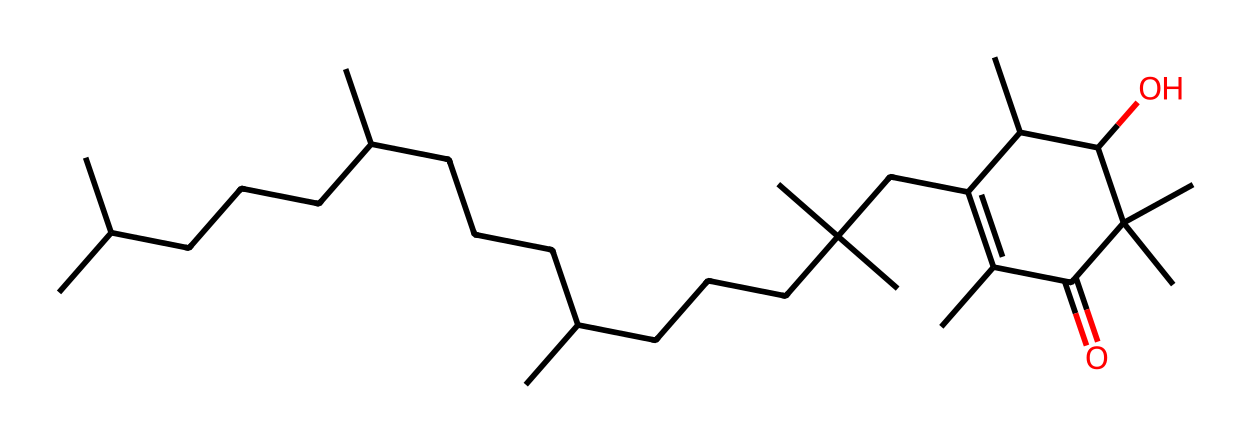What is the molecular formula of vitamin E? To determine the molecular formula from the provided SMILES, we need to count the number of each type of atom present in the chemical structure. Analyzing the SMILES reveals the presence of multiple carbon (C), hydrogen (H), and oxygen (O) atoms. The final count gives the formula: C29H50O2.
Answer: C29H50O2 How many oxygen atoms are present in vitamin E? By examining the SMILES representation, we can identify the number of oxygen atoms indicated by the 'O's present in the structure. Looking closely, there are exactly 2 oxygen atoms in vitamin E.
Answer: 2 What type of chemical bond predominates in vitamin E? The majority of connections made between carbon and hydrogen atoms in vitamin E are single bonds, which can be inferred from the structure's overall connectivity. This indicates that the predominant type of bond in vitamin E is the single bond.
Answer: single bond Does vitamin E have any double bonds in its structure? By inspecting the structure for any double bond indications (e.g., '=' in the SMILES), we find that there are indeed double bonds present, specifically between certain carbon atoms. This suggests that vitamin E contains double bonds in its structure.
Answer: yes What functional group is associated with the antioxidant properties of vitamin E? The antioxidant properties of vitamin E are largely attributed to the presence of the hydroxyl (-OH) functional group, which allows it to scavenge free radicals. The hydroxyl group is clearly present in the chemical structure.
Answer: hydroxyl group Which part of vitamin E's structure contributes to its lipophilic nature? The long hydrocarbon chains indicated by the extended carbon connections in the structure contribute significantly to the lipophilic nature of vitamin E. This is evident by the large number of carbon atoms compared to polar groups.
Answer: hydrocarbon chains What is one key role of vitamin E? Vitamin E primarily functions as an antioxidant, protecting cells from damage caused by free radicals. This role is well-established in nutritional biochemistry and corresponds to the properties observed from its structure.
Answer: antioxidant 